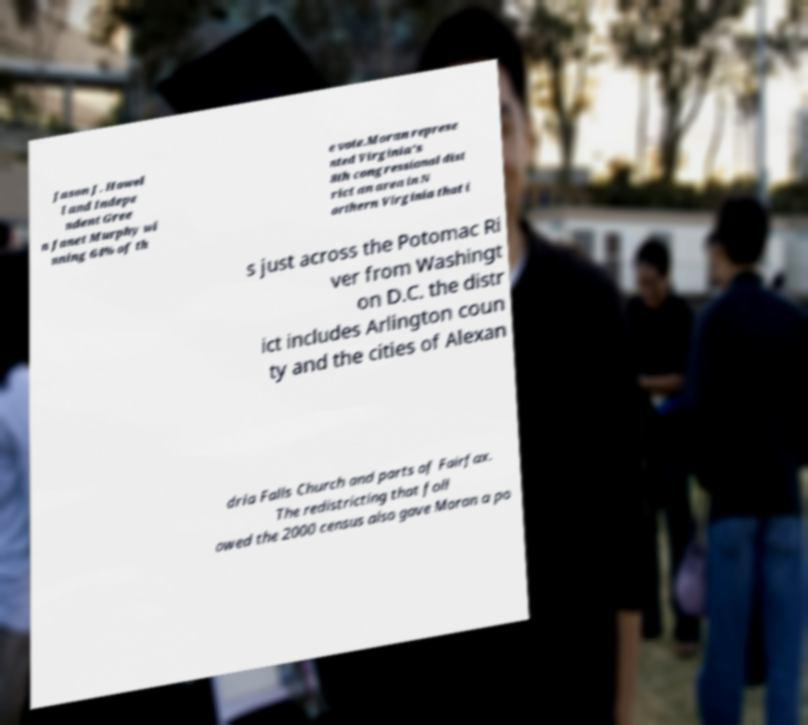I need the written content from this picture converted into text. Can you do that? Jason J. Howel l and Indepe ndent Gree n Janet Murphy wi nning 64% of th e vote.Moran represe nted Virginia's 8th congressional dist rict an area in N orthern Virginia that i s just across the Potomac Ri ver from Washingt on D.C. the distr ict includes Arlington coun ty and the cities of Alexan dria Falls Church and parts of Fairfax. The redistricting that foll owed the 2000 census also gave Moran a po 